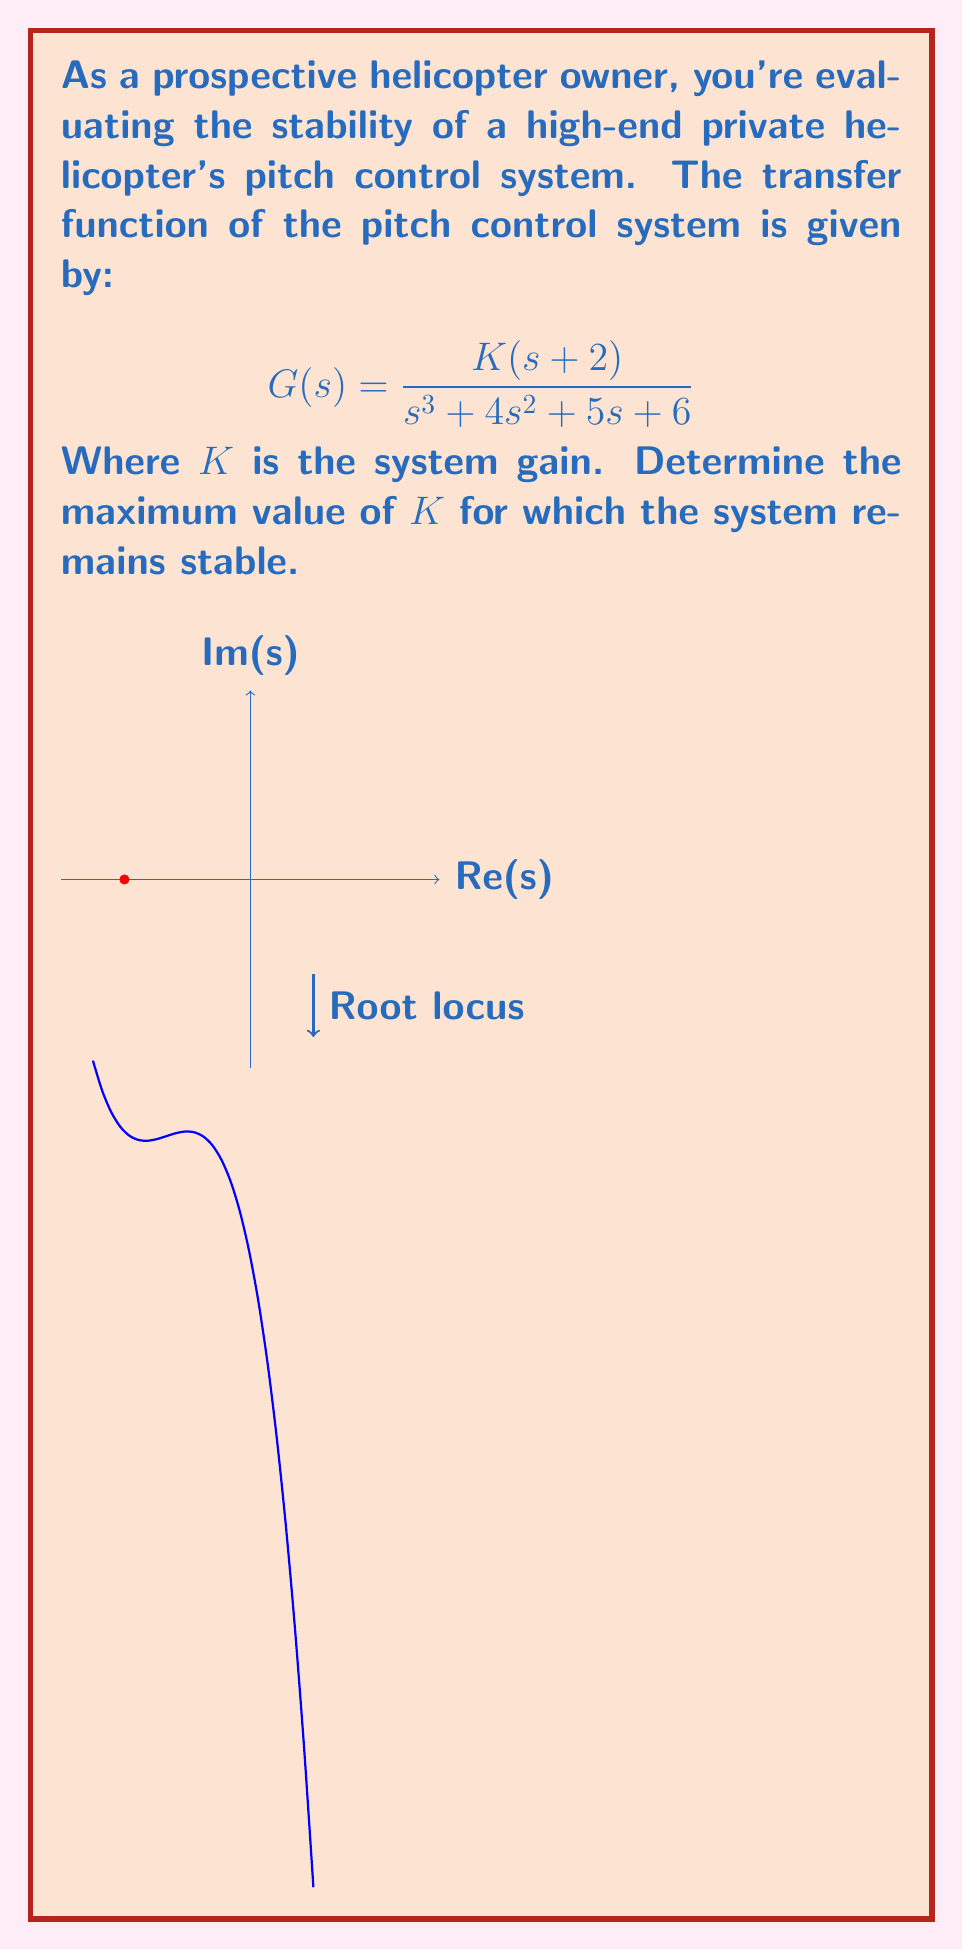What is the answer to this math problem? To analyze the stability of the helicopter's pitch control system, we'll use the Routh-Hurwitz stability criterion:

1) First, write the characteristic equation:
   $$s^3 + 4s^2 + 5s + (6+2K) = 0$$

2) Construct the Routh array:
   $$\begin{array}{c|cc}
   s^3 & 1 & 5 \\
   s^2 & 4 & 6+2K \\
   s^1 & b_1 & 0 \\
   s^0 & b_2 & 0
   \end{array}$$

   Where:
   $$b_1 = \frac{4(5) - 1(6+2K)}{4} = 5 - \frac{6+2K}{4}$$
   $$b_2 = \frac{b_1(6+2K) - 4(0)}{b_1} = 6+2K$$

3) For stability, all elements in the first column must be positive. Therefore:

   $1 > 0$ (always true)
   $4 > 0$ (always true)
   $b_1 > 0$, which means: $5 - \frac{6+2K}{4} > 0$
   $b_2 > 0$, which means: $6+2K > 0$

4) From $b_1 > 0$:
   $$5 - \frac{6+2K}{4} > 0$$
   $$20 - (6+2K) > 0$$
   $$14 - 2K > 0$$
   $$K < 7$$

5) From $b_2 > 0$:
   $$6+2K > 0$$
   $$K > -3$$

6) Combining the conditions: $-3 < K < 7$

Therefore, the maximum value of $K$ for which the system remains stable is just under 7.
Answer: $K_{max} = 7$ 